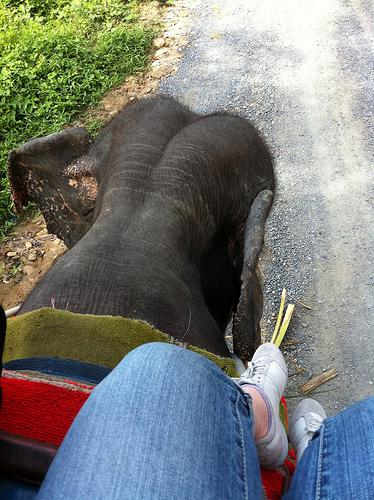Question: when was this picture taken?
Choices:
A. Outside, during the daytime.
B. Harvest time.
C. At the start of the party.
D. Happy hour.
Answer with the letter. Answer: A Question: where was this photo taken?
Choices:
A. In the city.
B. During an elephant ride.
C. From a cab.
D. Side of a mountain.
Answer with the letter. Answer: B Question: what is the person riding on?
Choices:
A. Harley.
B. Schwin.
C. An elephant.
D. Vespa.
Answer with the letter. Answer: C Question: what color are the person's shoes?
Choices:
A. Red.
B. White.
C. Yellow.
D. Green.
Answer with the letter. Answer: B 